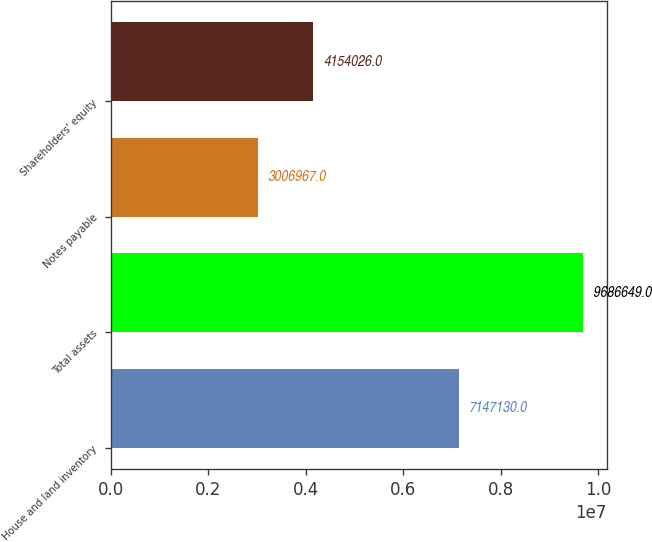Convert chart. <chart><loc_0><loc_0><loc_500><loc_500><bar_chart><fcel>House and land inventory<fcel>Total assets<fcel>Notes payable<fcel>Shareholders' equity<nl><fcel>7.14713e+06<fcel>9.68665e+06<fcel>3.00697e+06<fcel>4.15403e+06<nl></chart> 